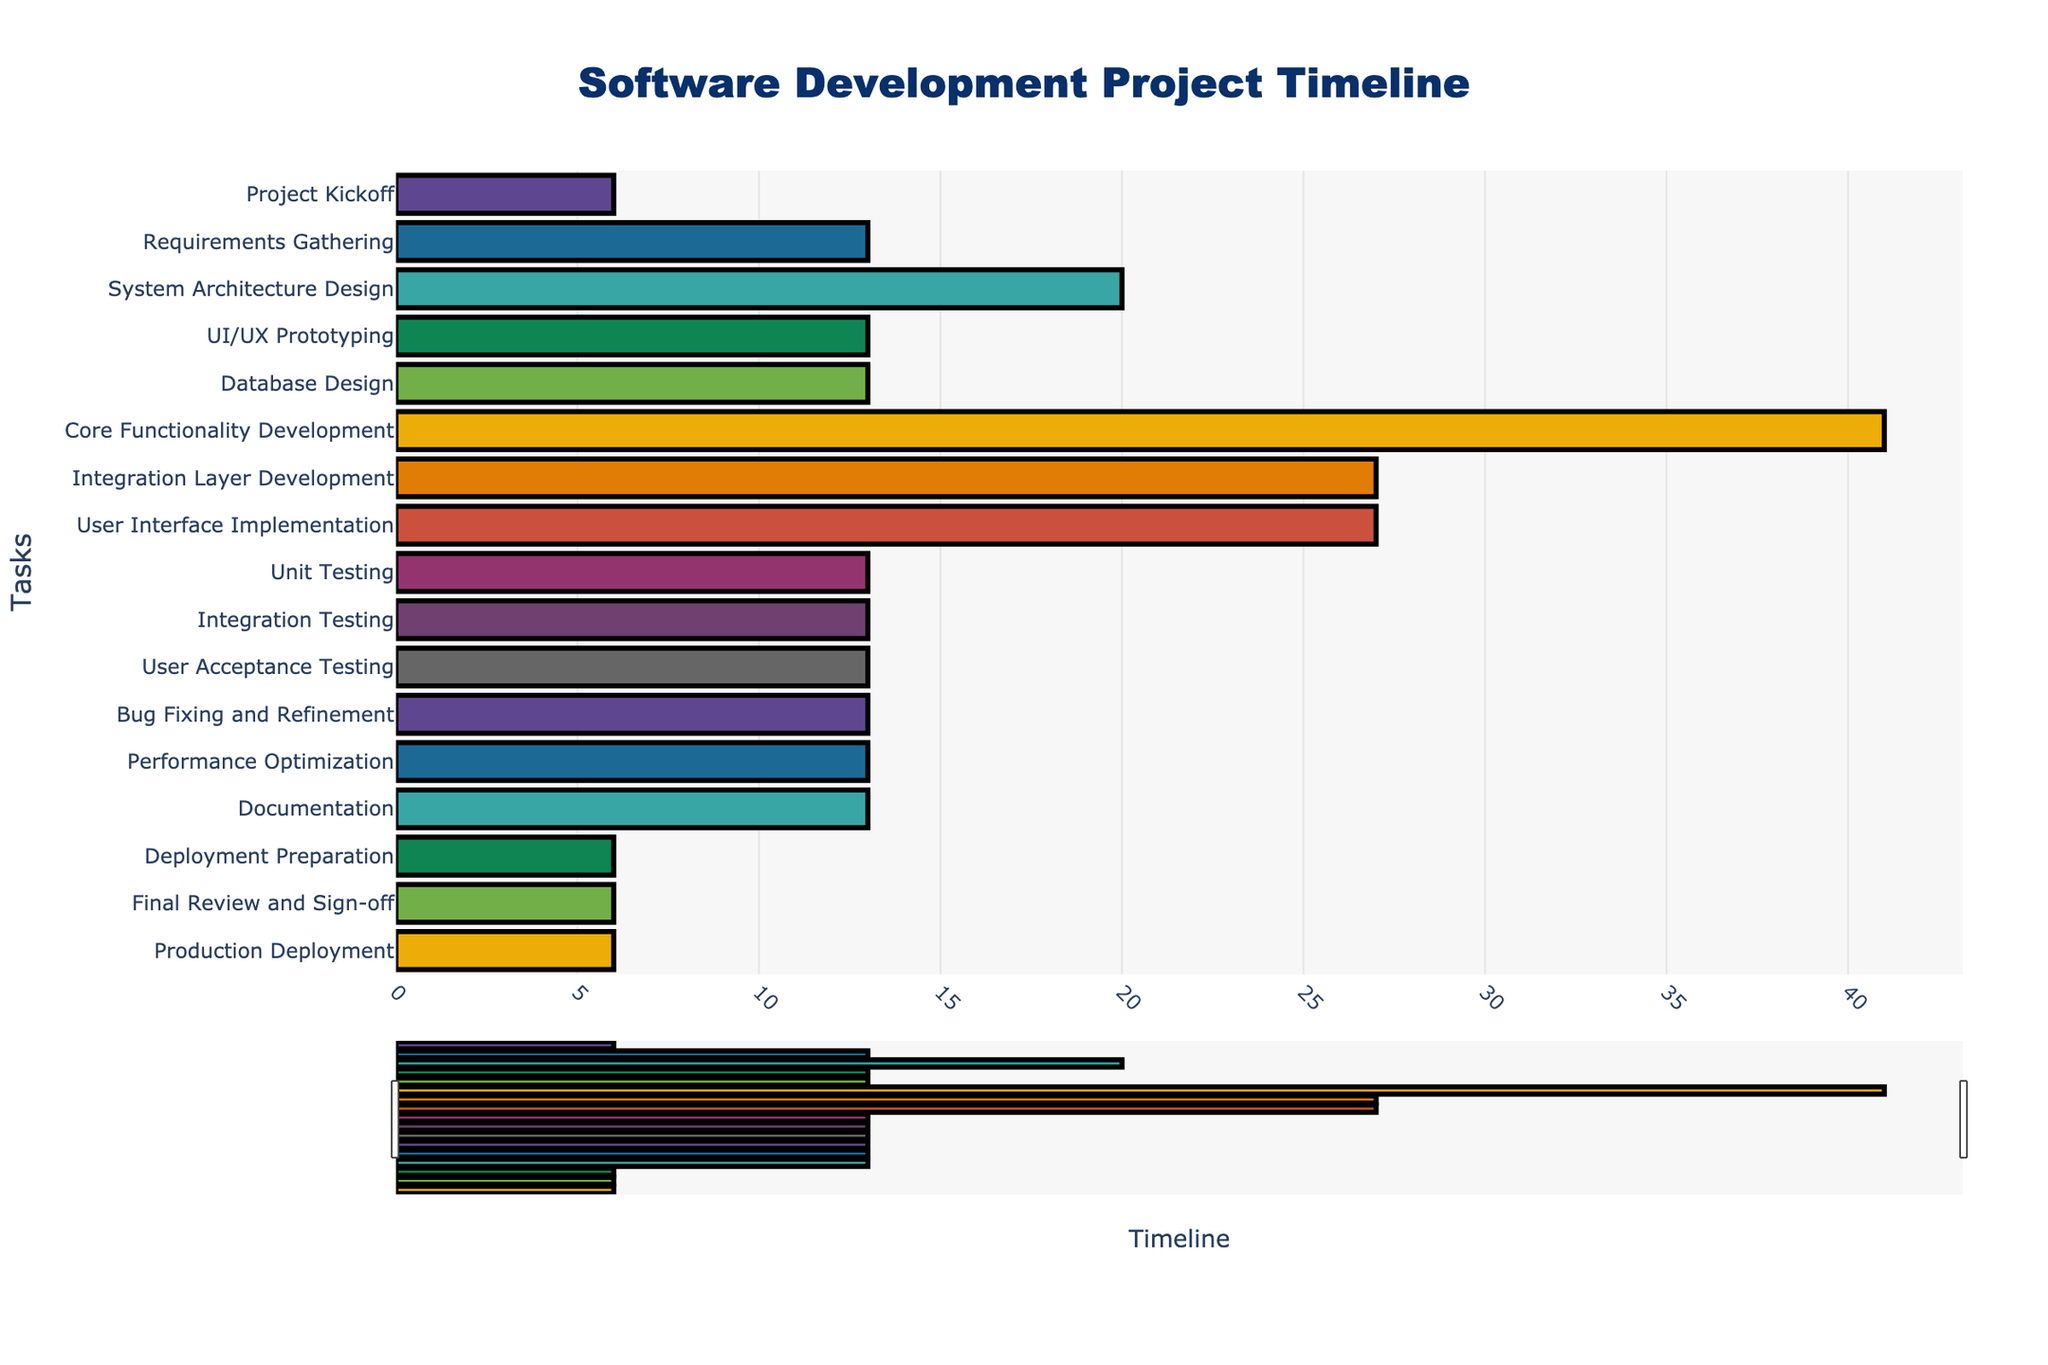What is the title of the Gantt Chart? The title of the Gantt Chart can be found at the top of the figure and reads "Software Development Project Timeline."
Answer: Software Development Project Timeline When does the first task start and when does it end? The first task, "Project Kickoff," starts on 2023-06-01 and ends on 2023-06-07. This can be verified by looking at the horizontal bar representing the task at the top of the chart.
Answer: 2023-06-01 to 2023-06-07 Which task has the longest duration? To find the task with the longest duration, look for the bar that spans the greatest distance on the x-axis. "Core Functionality Development" has the longest duration, lasting from 2023-07-27 to 2023-09-06, which is 41 days.
Answer: Core Functionality Development How many tasks are there in total? The total number of tasks can be determined by counting the number of horizontal bars (one for each task) listed along the y-axis. There are 17 tasks in total.
Answer: 17 Which tasks overlap with "Database Design" and during which dates? To find tasks that overlap with "Database Design," look for bars that start or end between 2023-07-13 and 2023-07-26. The overlapping tasks are "UI/UX Prototyping" (same dates), "Core Functionality Development" (starts on 2023-07-27), and "System Architecture Design" (ends on 2023-07-12, but closely aligned).
Answer: UI/UX Prototyping and System Architecture Design What is the total duration from the start of the first task to the end of the final task? The total duration is calculated by determining the start date of the first task and the end date of the final task. The project starts on 2023-06-01 and ends on 2023-12-20. Calculating the total duration, we get 202 days.
Answer: 202 days Compare the duration of "Unit Testing" and "Integration Testing." Which one is longer and by how many days? "Unit Testing" runs from 2023-09-07 to 2023-09-20, lasting 14 days. "Integration Testing" runs from 2023-09-21 to 2023-10-04, lasting 14 days. Both tests have the same duration, 14 days.
Answer: Both are the same duration During which months does "Performance Optimization" take place? "Performance Optimization" takes place between 2023-11-02 and 2023-11-15, which means it occurs in November.
Answer: November Identify the task that immediately follows "User Acceptance Testing." The task that immediately follows "User Acceptance Testing," which ends on 2023-10-18, is "Bug Fixing and Refinement," starting on 2023-10-19.
Answer: Bug Fixing and Refinement 